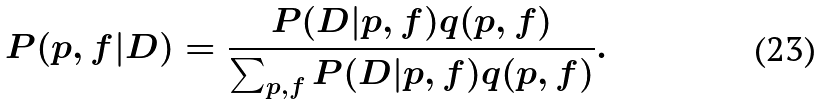<formula> <loc_0><loc_0><loc_500><loc_500>P ( p , f | D ) = \frac { P ( D | p , f ) q ( p , f ) } { \sum _ { p , f } P ( D | p , f ) q ( p , f ) } .</formula> 